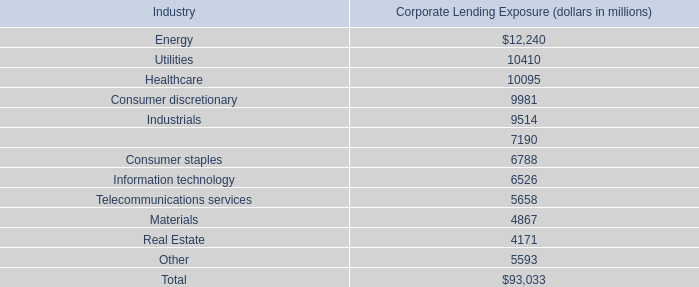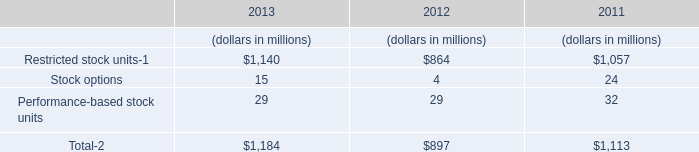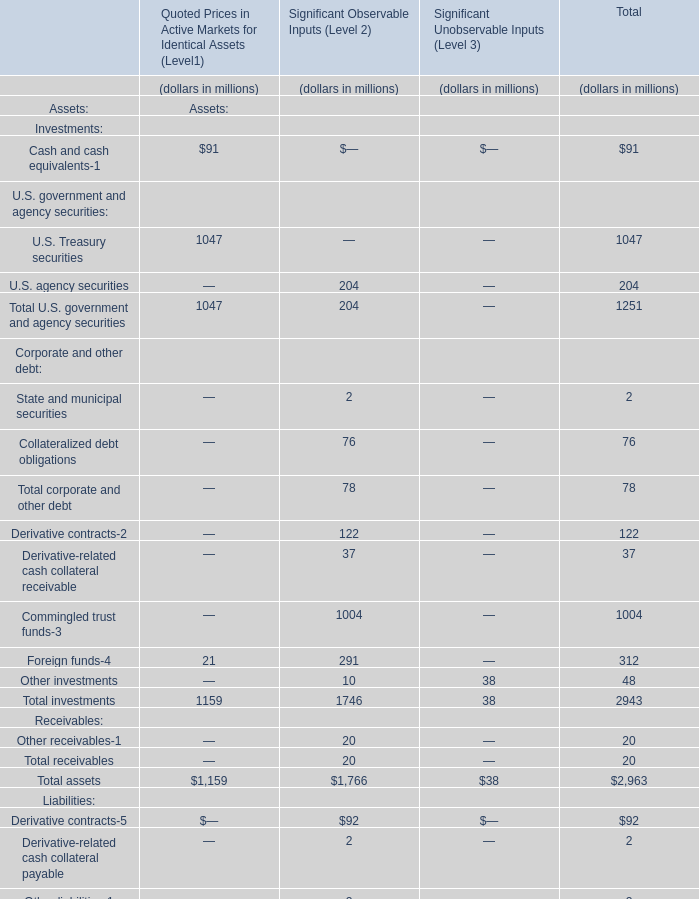consumer related loans make up how much of the companies total corporate lending exposure? 
Computations: ((9981 + 6788) / 93033)
Answer: 0.18025. 